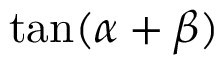Convert formula to latex. <formula><loc_0><loc_0><loc_500><loc_500>\tan ( \alpha + \beta )</formula> 